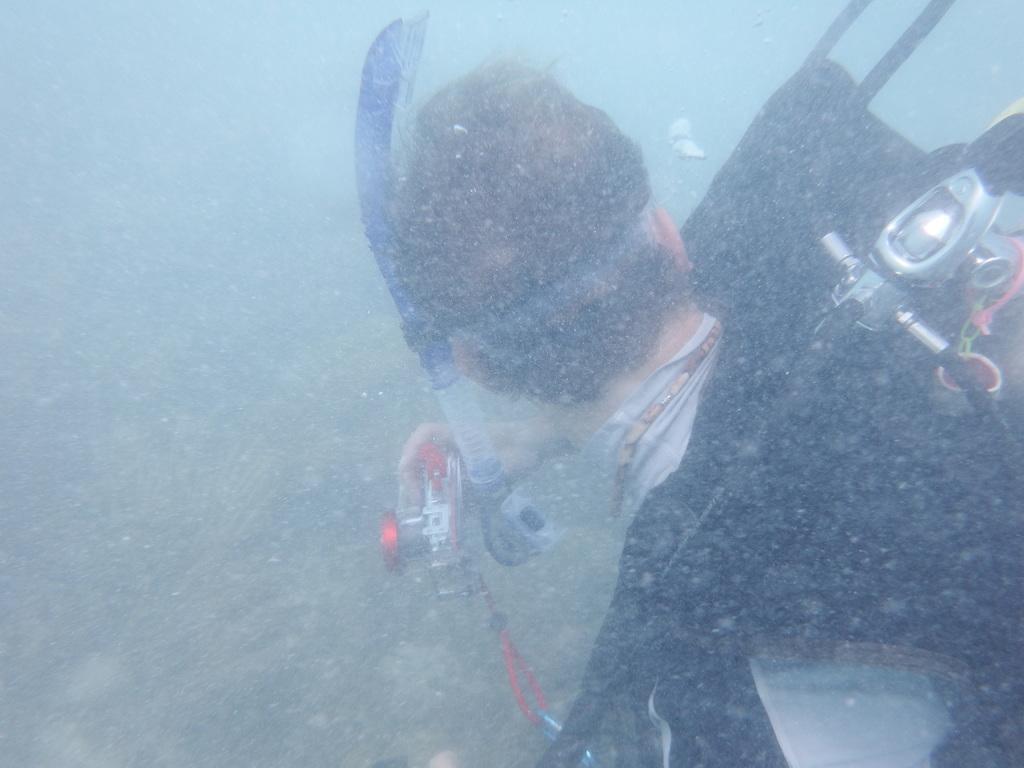Could you give a brief overview of what you see in this image? In this image I can see the person wearing the black and ash color dress and holding an object. The person is in the water. 